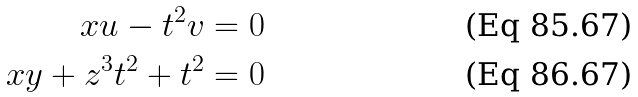Convert formula to latex. <formula><loc_0><loc_0><loc_500><loc_500>x u - t ^ { 2 } v = 0 \\ x y + z ^ { 3 } t ^ { 2 } + t ^ { 2 } = 0</formula> 